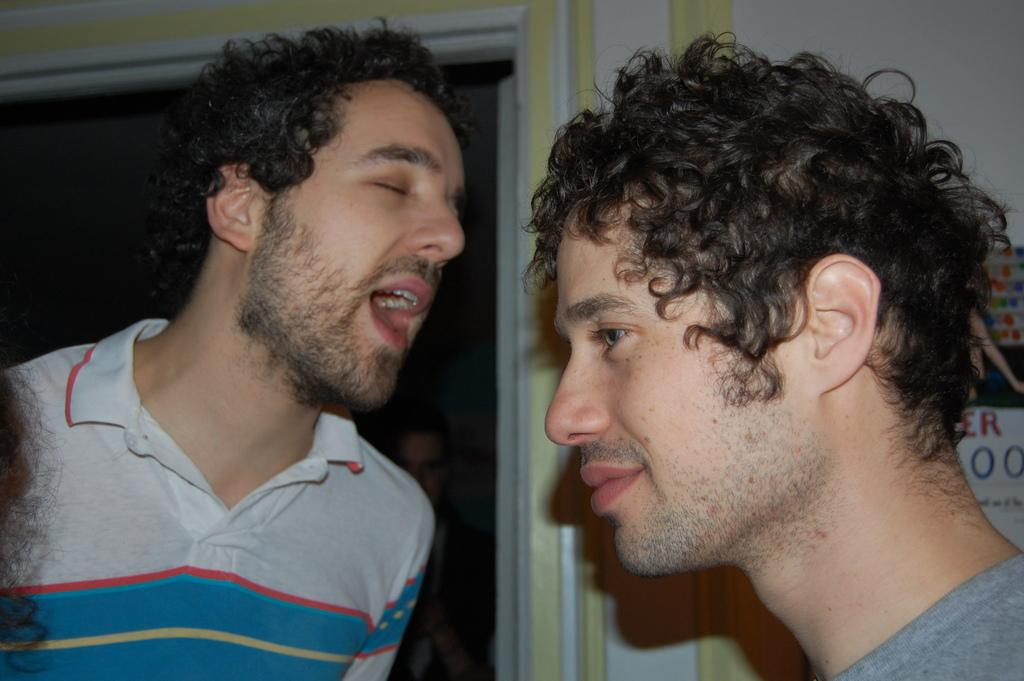What are the persons in the image wearing? The persons in the image are wearing dresses. What can be seen on the wall in the background of the image? There is a poster on the wall in the background of the image. What elements are present on the poster? The poster contains a photo and text. What type of ornament is hanging from the ceiling in the image? There is no ornament hanging from the ceiling in the image. What is the home like in the image? The provided facts do not give any information about the home or its characteristics. 